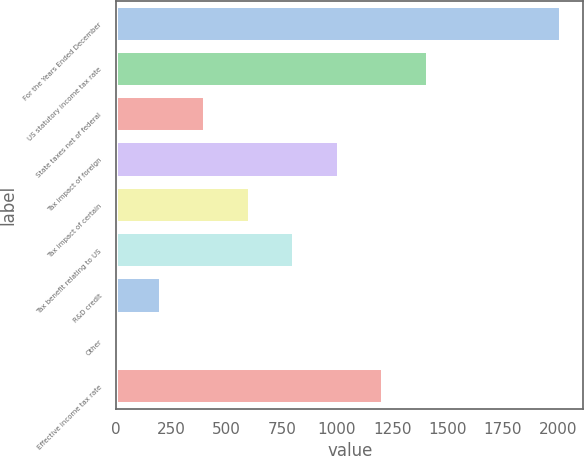Convert chart. <chart><loc_0><loc_0><loc_500><loc_500><bar_chart><fcel>For the Years Ended December<fcel>US statutory income tax rate<fcel>State taxes net of federal<fcel>Tax impact of foreign<fcel>Tax impact of certain<fcel>Tax benefit relating to US<fcel>R&D credit<fcel>Other<fcel>Effective income tax rate<nl><fcel>2014<fcel>1409.83<fcel>402.88<fcel>1007.05<fcel>604.27<fcel>805.66<fcel>201.49<fcel>0.1<fcel>1208.44<nl></chart> 